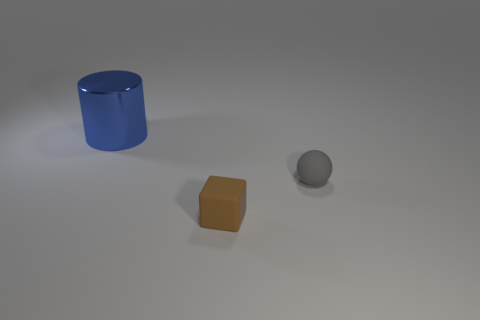Can you describe the surface the objects are resting on? The objects are resting on a smooth, matte surface that seems to have a slight curvature, dipping toward the edges of the frame. The neutral color of the surface ensures the objects remain the focal points of the image. 